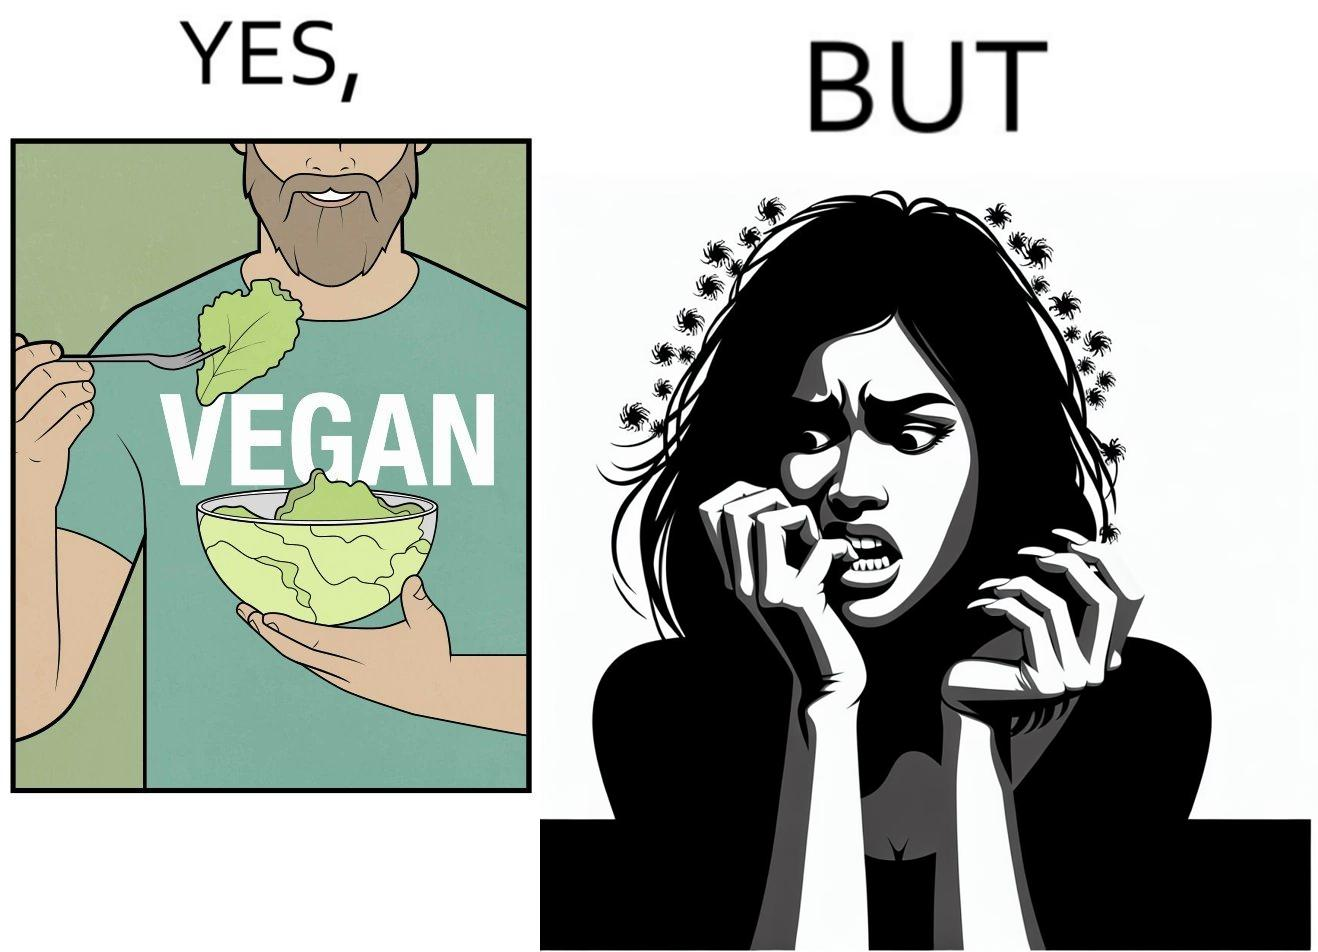Describe what you see in the left and right parts of this image. In the left part of the image: The image shows a man eating leafy vegetables out of a bowl in his hand. He is also wearing a t-shirt that says vegan. In the right part of the image: The image shows a person biting the skin around the fingernails of thier hand. 